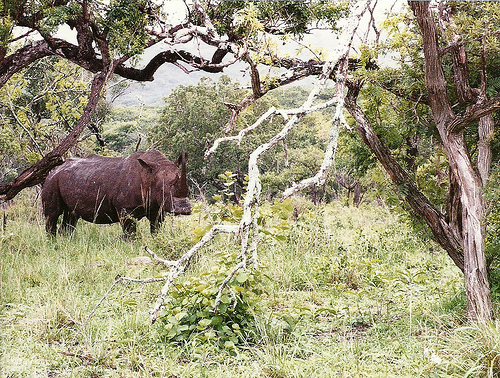<image>
Is there a animal to the left of the tree? Yes. From this viewpoint, the animal is positioned to the left side relative to the tree. Is the rhinoceros under the tree? Yes. The rhinoceros is positioned underneath the tree, with the tree above it in the vertical space. 